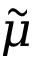Convert formula to latex. <formula><loc_0><loc_0><loc_500><loc_500>\tilde { \mu }</formula> 